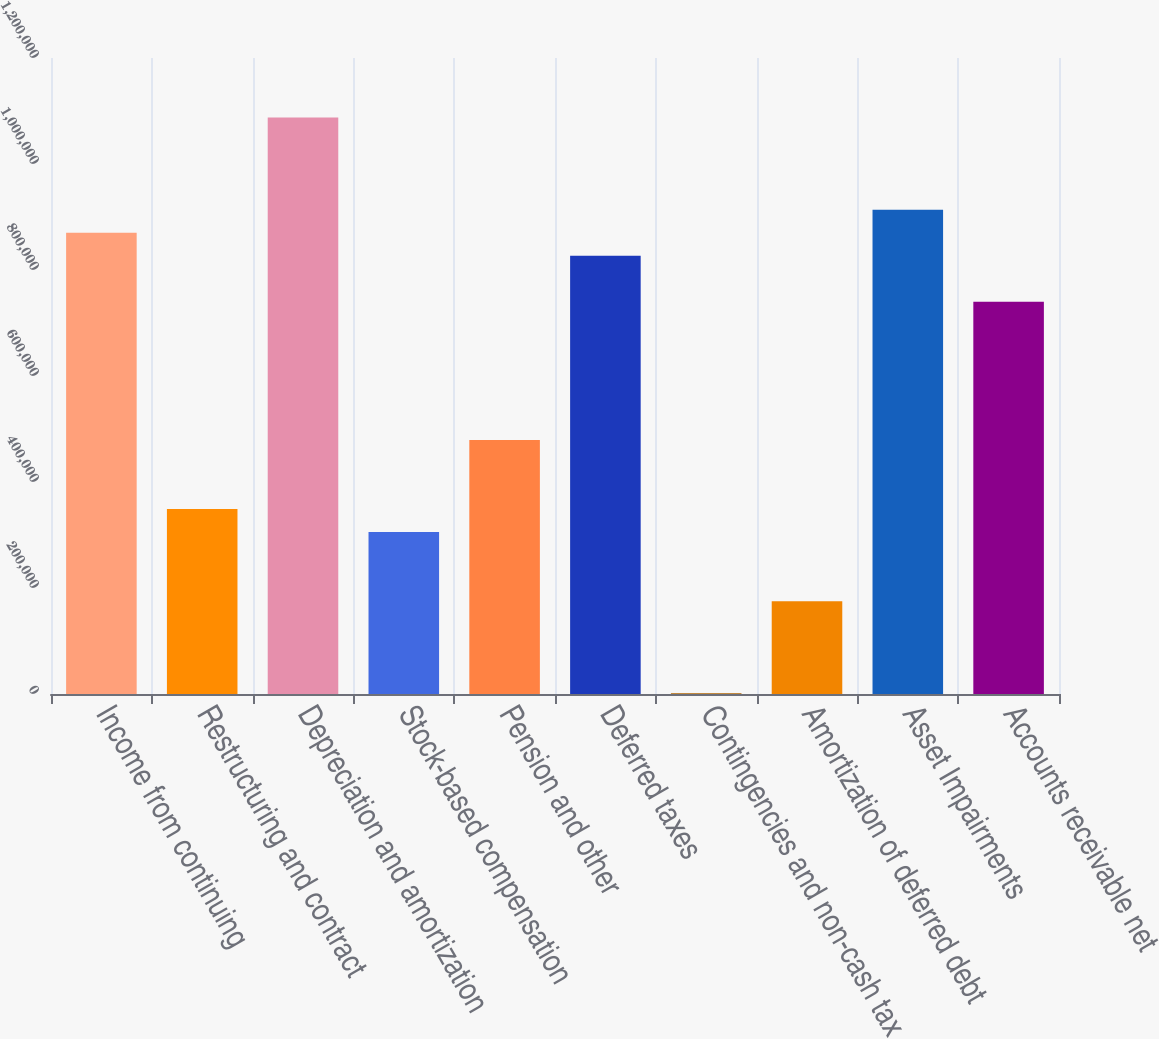Convert chart to OTSL. <chart><loc_0><loc_0><loc_500><loc_500><bar_chart><fcel>Income from continuing<fcel>Restructuring and contract<fcel>Depreciation and amortization<fcel>Stock-based compensation<fcel>Pension and other<fcel>Deferred taxes<fcel>Contingencies and non-cash tax<fcel>Amortization of deferred debt<fcel>Asset Impairments<fcel>Accounts receivable net<nl><fcel>870318<fcel>348956<fcel>1.08755e+06<fcel>305510<fcel>479297<fcel>826871<fcel>1382<fcel>175169<fcel>913765<fcel>739978<nl></chart> 